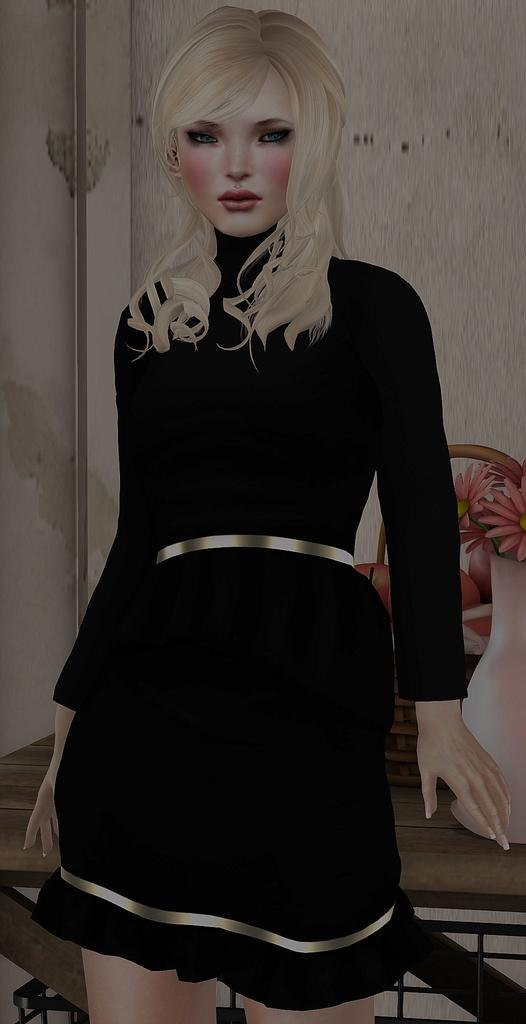Please provide a concise description of this image. This image is an animation, in this image there is a girl, behind here there is table, on that table there is a flower vase and fruits, in the background there is a wall. 